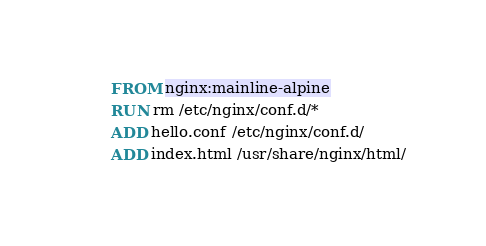Convert code to text. <code><loc_0><loc_0><loc_500><loc_500><_Dockerfile_>FROM nginx:mainline-alpine
RUN rm /etc/nginx/conf.d/*
ADD hello.conf /etc/nginx/conf.d/
ADD index.html /usr/share/nginx/html/
</code> 